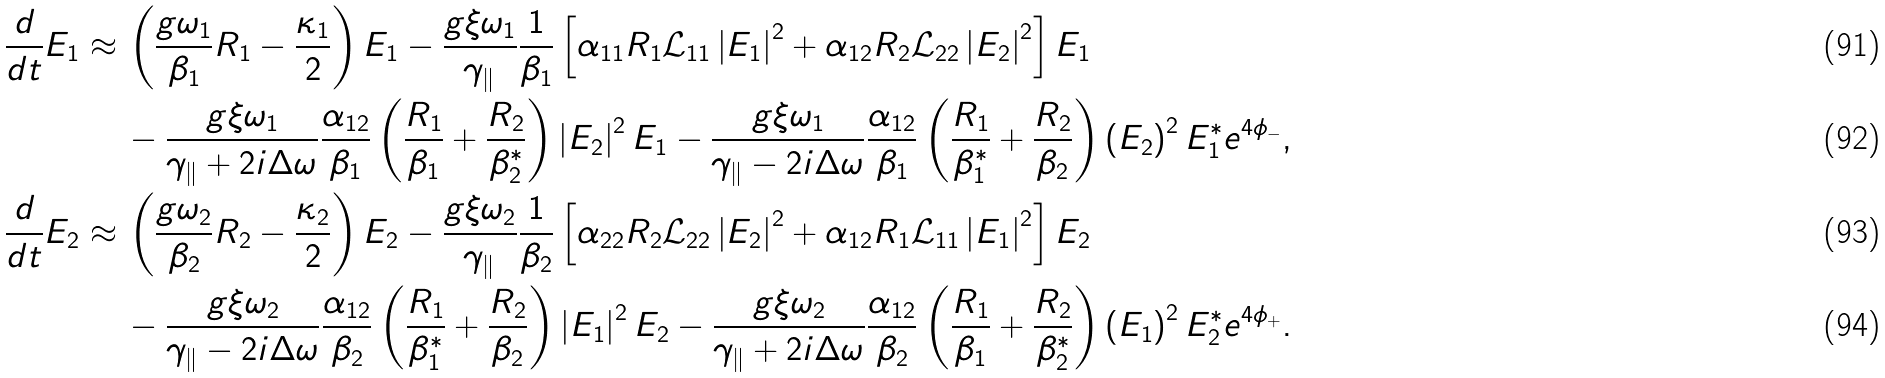<formula> <loc_0><loc_0><loc_500><loc_500>\frac { d } { d t } E _ { 1 } \approx \, & \left ( \frac { g \omega _ { 1 } } { \beta _ { 1 } } R _ { 1 } - \frac { \kappa _ { 1 } } { 2 } \right ) E _ { 1 } - \frac { g \xi \omega _ { 1 } } { \gamma _ { \| } } \frac { 1 } { \beta _ { 1 } } \left [ \alpha _ { 1 1 } R _ { 1 } \mathcal { L } _ { 1 1 } \left | E _ { 1 } \right | ^ { 2 } + \alpha _ { 1 2 } R _ { 2 } \mathcal { L } _ { 2 2 } \left | E _ { 2 } \right | ^ { 2 } \right ] E _ { 1 } \\ & - \frac { g \xi \omega _ { 1 } } { \gamma _ { \| } + 2 i \Delta \omega } \frac { \alpha _ { 1 2 } } { \beta _ { 1 } } \left ( \frac { R _ { 1 } } { \beta _ { 1 } } + \frac { R _ { 2 } } { \beta _ { 2 } ^ { * } } \right ) \left | E _ { 2 } \right | ^ { 2 } E _ { 1 } - \frac { g \xi \omega _ { 1 } } { \gamma _ { \| } - 2 i \Delta \omega } \frac { \alpha _ { 1 2 } } { \beta _ { 1 } } \left ( \frac { R _ { 1 } } { \beta _ { 1 } ^ { * } } + \frac { R _ { 2 } } { \beta _ { 2 } } \right ) \left ( E _ { 2 } \right ) ^ { 2 } E _ { 1 } ^ { * } e ^ { 4 \phi _ { - } } , \\ \frac { d } { d t } E _ { 2 } \approx \, & \left ( \frac { g \omega _ { 2 } } { \beta _ { 2 } } R _ { 2 } - \frac { \kappa _ { 2 } } { 2 } \right ) E _ { 2 } - \frac { g \xi \omega _ { 2 } } { \gamma _ { \| } } \frac { 1 } { \beta _ { 2 } } \left [ \alpha _ { 2 2 } R _ { 2 } \mathcal { L } _ { 2 2 } \left | E _ { 2 } \right | ^ { 2 } + \alpha _ { 1 2 } R _ { 1 } \mathcal { L } _ { 1 1 } \left | E _ { 1 } \right | ^ { 2 } \right ] E _ { 2 } \\ & - \frac { g \xi \omega _ { 2 } } { \gamma _ { \| } - 2 i \Delta \omega } \frac { \alpha _ { 1 2 } } { \beta _ { 2 } } \left ( \frac { R _ { 1 } } { \beta _ { 1 } ^ { * } } + \frac { R _ { 2 } } { \beta _ { 2 } } \right ) \left | E _ { 1 } \right | ^ { 2 } E _ { 2 } - \frac { g \xi \omega _ { 2 } } { \gamma _ { \| } + 2 i \Delta \omega } \frac { \alpha _ { 1 2 } } { \beta _ { 2 } } \left ( \frac { R _ { 1 } } { \beta _ { 1 } } + \frac { R _ { 2 } } { \beta _ { 2 } ^ { * } } \right ) \left ( E _ { 1 } \right ) ^ { 2 } E _ { 2 } ^ { * } e ^ { 4 \phi _ { + } } .</formula> 